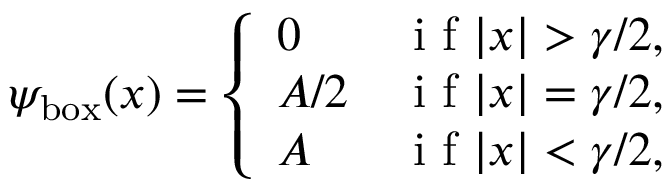Convert formula to latex. <formula><loc_0><loc_0><loc_500><loc_500>\psi _ { b o x } ( x ) = \left \{ \begin{array} { l l } { 0 } & { i f | x | > \gamma / 2 , } \\ { A / 2 } & { i f | x | = \gamma / 2 , } \\ { A } & { i f | x | < \gamma / 2 , } \end{array}</formula> 